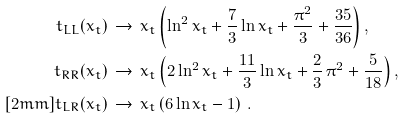<formula> <loc_0><loc_0><loc_500><loc_500>t _ { L L } ( x _ { t } ) & \, \to \, x _ { t } \left ( \ln ^ { 2 } x _ { t } + \frac { 7 } { 3 } \ln x _ { t } + \frac { \pi ^ { 2 } } { 3 } + \frac { 3 5 } { 3 6 } \right ) , \\ t _ { R R } ( x _ { t } ) & \, \to \, x _ { t } \left ( 2 \ln ^ { 2 } x _ { t } + \frac { 1 1 } { 3 } \ln x _ { t } + \frac { 2 } { 3 } \, \pi ^ { 2 } + \frac { 5 } { 1 8 } \right ) , \\ [ 2 m m ] t _ { L R } ( x _ { t } ) & \, \to \, x _ { t } \left ( 6 \ln x _ { t } - 1 \right ) \, .</formula> 